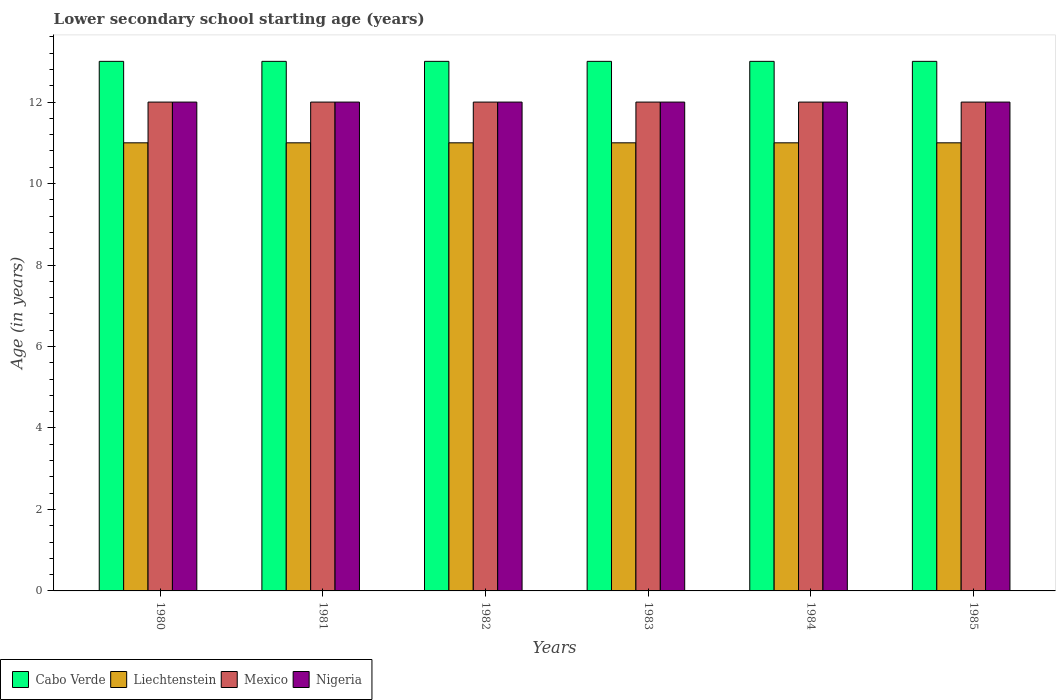How many groups of bars are there?
Give a very brief answer. 6. Are the number of bars on each tick of the X-axis equal?
Offer a very short reply. Yes. How many bars are there on the 5th tick from the right?
Make the answer very short. 4. What is the label of the 1st group of bars from the left?
Provide a short and direct response. 1980. In how many cases, is the number of bars for a given year not equal to the number of legend labels?
Your answer should be compact. 0. What is the lower secondary school starting age of children in Nigeria in 1980?
Your answer should be compact. 12. Across all years, what is the maximum lower secondary school starting age of children in Liechtenstein?
Your answer should be compact. 11. Across all years, what is the minimum lower secondary school starting age of children in Liechtenstein?
Give a very brief answer. 11. In which year was the lower secondary school starting age of children in Mexico minimum?
Your answer should be very brief. 1980. What is the total lower secondary school starting age of children in Mexico in the graph?
Give a very brief answer. 72. What is the difference between the lower secondary school starting age of children in Mexico in 1981 and the lower secondary school starting age of children in Liechtenstein in 1980?
Your response must be concise. 1. What is the average lower secondary school starting age of children in Liechtenstein per year?
Your response must be concise. 11. In the year 1984, what is the difference between the lower secondary school starting age of children in Mexico and lower secondary school starting age of children in Nigeria?
Your answer should be compact. 0. In how many years, is the lower secondary school starting age of children in Liechtenstein greater than 8.4 years?
Your response must be concise. 6. What is the ratio of the lower secondary school starting age of children in Mexico in 1982 to that in 1983?
Offer a terse response. 1. Is the lower secondary school starting age of children in Cabo Verde in 1983 less than that in 1985?
Offer a terse response. No. Is the difference between the lower secondary school starting age of children in Mexico in 1981 and 1983 greater than the difference between the lower secondary school starting age of children in Nigeria in 1981 and 1983?
Keep it short and to the point. No. What is the difference between the highest and the lowest lower secondary school starting age of children in Cabo Verde?
Keep it short and to the point. 0. What does the 2nd bar from the left in 1981 represents?
Offer a very short reply. Liechtenstein. What does the 3rd bar from the right in 1980 represents?
Provide a short and direct response. Liechtenstein. How many years are there in the graph?
Offer a very short reply. 6. What is the difference between two consecutive major ticks on the Y-axis?
Your answer should be very brief. 2. Does the graph contain grids?
Offer a very short reply. No. How many legend labels are there?
Your answer should be compact. 4. How are the legend labels stacked?
Give a very brief answer. Horizontal. What is the title of the graph?
Give a very brief answer. Lower secondary school starting age (years). What is the label or title of the Y-axis?
Provide a short and direct response. Age (in years). What is the Age (in years) in Cabo Verde in 1980?
Make the answer very short. 13. What is the Age (in years) of Liechtenstein in 1980?
Your answer should be very brief. 11. What is the Age (in years) of Mexico in 1980?
Your answer should be compact. 12. What is the Age (in years) of Nigeria in 1980?
Provide a short and direct response. 12. What is the Age (in years) of Liechtenstein in 1982?
Provide a short and direct response. 11. What is the Age (in years) in Cabo Verde in 1983?
Provide a short and direct response. 13. What is the Age (in years) of Cabo Verde in 1984?
Provide a short and direct response. 13. What is the Age (in years) of Liechtenstein in 1984?
Give a very brief answer. 11. What is the Age (in years) of Mexico in 1984?
Offer a terse response. 12. What is the Age (in years) of Nigeria in 1984?
Offer a very short reply. 12. What is the Age (in years) in Cabo Verde in 1985?
Provide a succinct answer. 13. What is the Age (in years) in Mexico in 1985?
Your answer should be very brief. 12. What is the Age (in years) of Nigeria in 1985?
Keep it short and to the point. 12. Across all years, what is the maximum Age (in years) of Cabo Verde?
Keep it short and to the point. 13. Across all years, what is the maximum Age (in years) in Mexico?
Offer a terse response. 12. Across all years, what is the minimum Age (in years) of Cabo Verde?
Offer a terse response. 13. Across all years, what is the minimum Age (in years) of Nigeria?
Make the answer very short. 12. What is the total Age (in years) in Cabo Verde in the graph?
Your answer should be compact. 78. What is the total Age (in years) in Liechtenstein in the graph?
Provide a succinct answer. 66. What is the difference between the Age (in years) of Nigeria in 1980 and that in 1981?
Your answer should be compact. 0. What is the difference between the Age (in years) of Cabo Verde in 1980 and that in 1982?
Provide a succinct answer. 0. What is the difference between the Age (in years) of Liechtenstein in 1980 and that in 1982?
Your answer should be compact. 0. What is the difference between the Age (in years) in Mexico in 1980 and that in 1982?
Ensure brevity in your answer.  0. What is the difference between the Age (in years) in Cabo Verde in 1980 and that in 1983?
Your response must be concise. 0. What is the difference between the Age (in years) in Liechtenstein in 1980 and that in 1983?
Offer a very short reply. 0. What is the difference between the Age (in years) in Cabo Verde in 1980 and that in 1984?
Your answer should be very brief. 0. What is the difference between the Age (in years) of Mexico in 1980 and that in 1984?
Your answer should be compact. 0. What is the difference between the Age (in years) in Nigeria in 1980 and that in 1984?
Give a very brief answer. 0. What is the difference between the Age (in years) of Cabo Verde in 1980 and that in 1985?
Provide a short and direct response. 0. What is the difference between the Age (in years) of Liechtenstein in 1980 and that in 1985?
Provide a succinct answer. 0. What is the difference between the Age (in years) of Mexico in 1981 and that in 1982?
Keep it short and to the point. 0. What is the difference between the Age (in years) in Nigeria in 1981 and that in 1982?
Your answer should be compact. 0. What is the difference between the Age (in years) of Cabo Verde in 1981 and that in 1983?
Provide a succinct answer. 0. What is the difference between the Age (in years) in Mexico in 1981 and that in 1983?
Offer a very short reply. 0. What is the difference between the Age (in years) in Mexico in 1981 and that in 1984?
Provide a short and direct response. 0. What is the difference between the Age (in years) in Mexico in 1982 and that in 1983?
Ensure brevity in your answer.  0. What is the difference between the Age (in years) of Cabo Verde in 1982 and that in 1984?
Your answer should be compact. 0. What is the difference between the Age (in years) of Nigeria in 1982 and that in 1984?
Ensure brevity in your answer.  0. What is the difference between the Age (in years) in Cabo Verde in 1982 and that in 1985?
Keep it short and to the point. 0. What is the difference between the Age (in years) in Liechtenstein in 1982 and that in 1985?
Make the answer very short. 0. What is the difference between the Age (in years) in Nigeria in 1983 and that in 1984?
Ensure brevity in your answer.  0. What is the difference between the Age (in years) in Liechtenstein in 1983 and that in 1985?
Your answer should be compact. 0. What is the difference between the Age (in years) of Cabo Verde in 1984 and that in 1985?
Your answer should be very brief. 0. What is the difference between the Age (in years) in Mexico in 1984 and that in 1985?
Your answer should be compact. 0. What is the difference between the Age (in years) in Cabo Verde in 1980 and the Age (in years) in Liechtenstein in 1981?
Make the answer very short. 2. What is the difference between the Age (in years) of Liechtenstein in 1980 and the Age (in years) of Nigeria in 1981?
Make the answer very short. -1. What is the difference between the Age (in years) in Cabo Verde in 1980 and the Age (in years) in Liechtenstein in 1983?
Ensure brevity in your answer.  2. What is the difference between the Age (in years) in Cabo Verde in 1980 and the Age (in years) in Nigeria in 1983?
Make the answer very short. 1. What is the difference between the Age (in years) of Liechtenstein in 1980 and the Age (in years) of Mexico in 1983?
Give a very brief answer. -1. What is the difference between the Age (in years) of Mexico in 1980 and the Age (in years) of Nigeria in 1983?
Your response must be concise. 0. What is the difference between the Age (in years) of Cabo Verde in 1980 and the Age (in years) of Liechtenstein in 1984?
Your answer should be compact. 2. What is the difference between the Age (in years) in Cabo Verde in 1980 and the Age (in years) in Mexico in 1984?
Provide a succinct answer. 1. What is the difference between the Age (in years) of Mexico in 1980 and the Age (in years) of Nigeria in 1984?
Provide a succinct answer. 0. What is the difference between the Age (in years) in Cabo Verde in 1980 and the Age (in years) in Liechtenstein in 1985?
Keep it short and to the point. 2. What is the difference between the Age (in years) in Liechtenstein in 1980 and the Age (in years) in Mexico in 1985?
Offer a terse response. -1. What is the difference between the Age (in years) in Liechtenstein in 1980 and the Age (in years) in Nigeria in 1985?
Provide a succinct answer. -1. What is the difference between the Age (in years) of Mexico in 1980 and the Age (in years) of Nigeria in 1985?
Offer a very short reply. 0. What is the difference between the Age (in years) of Cabo Verde in 1981 and the Age (in years) of Liechtenstein in 1982?
Your answer should be compact. 2. What is the difference between the Age (in years) in Cabo Verde in 1981 and the Age (in years) in Nigeria in 1982?
Offer a terse response. 1. What is the difference between the Age (in years) of Liechtenstein in 1981 and the Age (in years) of Nigeria in 1982?
Provide a short and direct response. -1. What is the difference between the Age (in years) in Cabo Verde in 1981 and the Age (in years) in Liechtenstein in 1983?
Offer a terse response. 2. What is the difference between the Age (in years) of Cabo Verde in 1981 and the Age (in years) of Mexico in 1983?
Your answer should be very brief. 1. What is the difference between the Age (in years) in Cabo Verde in 1981 and the Age (in years) in Nigeria in 1983?
Make the answer very short. 1. What is the difference between the Age (in years) in Liechtenstein in 1981 and the Age (in years) in Nigeria in 1983?
Your answer should be compact. -1. What is the difference between the Age (in years) in Cabo Verde in 1981 and the Age (in years) in Liechtenstein in 1984?
Your response must be concise. 2. What is the difference between the Age (in years) of Cabo Verde in 1981 and the Age (in years) of Nigeria in 1984?
Provide a succinct answer. 1. What is the difference between the Age (in years) in Liechtenstein in 1981 and the Age (in years) in Nigeria in 1984?
Provide a short and direct response. -1. What is the difference between the Age (in years) in Cabo Verde in 1981 and the Age (in years) in Mexico in 1985?
Keep it short and to the point. 1. What is the difference between the Age (in years) in Liechtenstein in 1981 and the Age (in years) in Nigeria in 1985?
Ensure brevity in your answer.  -1. What is the difference between the Age (in years) in Cabo Verde in 1982 and the Age (in years) in Nigeria in 1983?
Offer a very short reply. 1. What is the difference between the Age (in years) of Liechtenstein in 1982 and the Age (in years) of Nigeria in 1983?
Offer a terse response. -1. What is the difference between the Age (in years) of Liechtenstein in 1982 and the Age (in years) of Mexico in 1984?
Your response must be concise. -1. What is the difference between the Age (in years) of Cabo Verde in 1982 and the Age (in years) of Mexico in 1985?
Offer a very short reply. 1. What is the difference between the Age (in years) of Cabo Verde in 1982 and the Age (in years) of Nigeria in 1985?
Give a very brief answer. 1. What is the difference between the Age (in years) in Liechtenstein in 1982 and the Age (in years) in Mexico in 1985?
Your answer should be compact. -1. What is the difference between the Age (in years) of Liechtenstein in 1982 and the Age (in years) of Nigeria in 1985?
Provide a short and direct response. -1. What is the difference between the Age (in years) in Cabo Verde in 1983 and the Age (in years) in Liechtenstein in 1984?
Give a very brief answer. 2. What is the difference between the Age (in years) of Cabo Verde in 1983 and the Age (in years) of Mexico in 1984?
Make the answer very short. 1. What is the difference between the Age (in years) in Cabo Verde in 1983 and the Age (in years) in Nigeria in 1984?
Provide a succinct answer. 1. What is the difference between the Age (in years) of Liechtenstein in 1983 and the Age (in years) of Nigeria in 1984?
Your response must be concise. -1. What is the difference between the Age (in years) in Mexico in 1983 and the Age (in years) in Nigeria in 1984?
Your answer should be compact. 0. What is the difference between the Age (in years) of Cabo Verde in 1983 and the Age (in years) of Liechtenstein in 1985?
Your answer should be compact. 2. What is the difference between the Age (in years) in Cabo Verde in 1983 and the Age (in years) in Nigeria in 1985?
Offer a very short reply. 1. What is the difference between the Age (in years) in Liechtenstein in 1983 and the Age (in years) in Mexico in 1985?
Your response must be concise. -1. What is the difference between the Age (in years) of Cabo Verde in 1984 and the Age (in years) of Mexico in 1985?
Give a very brief answer. 1. What is the average Age (in years) of Mexico per year?
Offer a very short reply. 12. In the year 1980, what is the difference between the Age (in years) of Cabo Verde and Age (in years) of Liechtenstein?
Provide a short and direct response. 2. In the year 1980, what is the difference between the Age (in years) in Cabo Verde and Age (in years) in Nigeria?
Provide a succinct answer. 1. In the year 1980, what is the difference between the Age (in years) of Liechtenstein and Age (in years) of Nigeria?
Make the answer very short. -1. In the year 1980, what is the difference between the Age (in years) of Mexico and Age (in years) of Nigeria?
Offer a terse response. 0. In the year 1981, what is the difference between the Age (in years) of Cabo Verde and Age (in years) of Liechtenstein?
Provide a succinct answer. 2. In the year 1981, what is the difference between the Age (in years) in Liechtenstein and Age (in years) in Mexico?
Keep it short and to the point. -1. In the year 1981, what is the difference between the Age (in years) of Liechtenstein and Age (in years) of Nigeria?
Keep it short and to the point. -1. In the year 1982, what is the difference between the Age (in years) of Cabo Verde and Age (in years) of Liechtenstein?
Provide a succinct answer. 2. In the year 1983, what is the difference between the Age (in years) of Cabo Verde and Age (in years) of Mexico?
Your response must be concise. 1. In the year 1984, what is the difference between the Age (in years) in Cabo Verde and Age (in years) in Liechtenstein?
Give a very brief answer. 2. In the year 1984, what is the difference between the Age (in years) in Cabo Verde and Age (in years) in Nigeria?
Your answer should be very brief. 1. In the year 1984, what is the difference between the Age (in years) of Liechtenstein and Age (in years) of Mexico?
Give a very brief answer. -1. In the year 1984, what is the difference between the Age (in years) of Mexico and Age (in years) of Nigeria?
Keep it short and to the point. 0. In the year 1985, what is the difference between the Age (in years) of Cabo Verde and Age (in years) of Liechtenstein?
Offer a very short reply. 2. In the year 1985, what is the difference between the Age (in years) in Cabo Verde and Age (in years) in Nigeria?
Your answer should be compact. 1. In the year 1985, what is the difference between the Age (in years) in Liechtenstein and Age (in years) in Mexico?
Provide a short and direct response. -1. In the year 1985, what is the difference between the Age (in years) in Mexico and Age (in years) in Nigeria?
Offer a terse response. 0. What is the ratio of the Age (in years) of Liechtenstein in 1980 to that in 1981?
Provide a succinct answer. 1. What is the ratio of the Age (in years) in Mexico in 1980 to that in 1981?
Offer a terse response. 1. What is the ratio of the Age (in years) in Cabo Verde in 1980 to that in 1982?
Give a very brief answer. 1. What is the ratio of the Age (in years) in Liechtenstein in 1980 to that in 1982?
Ensure brevity in your answer.  1. What is the ratio of the Age (in years) in Nigeria in 1980 to that in 1982?
Your answer should be compact. 1. What is the ratio of the Age (in years) in Cabo Verde in 1980 to that in 1983?
Offer a very short reply. 1. What is the ratio of the Age (in years) of Mexico in 1980 to that in 1983?
Offer a terse response. 1. What is the ratio of the Age (in years) in Nigeria in 1980 to that in 1984?
Keep it short and to the point. 1. What is the ratio of the Age (in years) in Liechtenstein in 1980 to that in 1985?
Give a very brief answer. 1. What is the ratio of the Age (in years) in Nigeria in 1980 to that in 1985?
Your answer should be very brief. 1. What is the ratio of the Age (in years) in Cabo Verde in 1981 to that in 1982?
Give a very brief answer. 1. What is the ratio of the Age (in years) of Liechtenstein in 1981 to that in 1982?
Your answer should be very brief. 1. What is the ratio of the Age (in years) of Mexico in 1981 to that in 1982?
Make the answer very short. 1. What is the ratio of the Age (in years) in Nigeria in 1981 to that in 1982?
Your answer should be compact. 1. What is the ratio of the Age (in years) in Liechtenstein in 1981 to that in 1983?
Your answer should be very brief. 1. What is the ratio of the Age (in years) in Mexico in 1981 to that in 1983?
Provide a succinct answer. 1. What is the ratio of the Age (in years) in Cabo Verde in 1981 to that in 1984?
Offer a very short reply. 1. What is the ratio of the Age (in years) of Liechtenstein in 1981 to that in 1984?
Ensure brevity in your answer.  1. What is the ratio of the Age (in years) of Mexico in 1981 to that in 1984?
Provide a short and direct response. 1. What is the ratio of the Age (in years) of Nigeria in 1981 to that in 1984?
Your answer should be compact. 1. What is the ratio of the Age (in years) in Cabo Verde in 1981 to that in 1985?
Make the answer very short. 1. What is the ratio of the Age (in years) of Mexico in 1982 to that in 1983?
Your response must be concise. 1. What is the ratio of the Age (in years) in Liechtenstein in 1982 to that in 1984?
Make the answer very short. 1. What is the ratio of the Age (in years) in Cabo Verde in 1982 to that in 1985?
Provide a succinct answer. 1. What is the ratio of the Age (in years) of Mexico in 1982 to that in 1985?
Ensure brevity in your answer.  1. What is the ratio of the Age (in years) of Nigeria in 1982 to that in 1985?
Ensure brevity in your answer.  1. What is the ratio of the Age (in years) of Liechtenstein in 1983 to that in 1984?
Provide a short and direct response. 1. What is the ratio of the Age (in years) in Cabo Verde in 1983 to that in 1985?
Ensure brevity in your answer.  1. What is the ratio of the Age (in years) of Mexico in 1983 to that in 1985?
Keep it short and to the point. 1. What is the ratio of the Age (in years) of Liechtenstein in 1984 to that in 1985?
Offer a very short reply. 1. What is the ratio of the Age (in years) of Nigeria in 1984 to that in 1985?
Make the answer very short. 1. What is the difference between the highest and the second highest Age (in years) in Cabo Verde?
Make the answer very short. 0. What is the difference between the highest and the second highest Age (in years) of Mexico?
Keep it short and to the point. 0. What is the difference between the highest and the lowest Age (in years) in Liechtenstein?
Offer a very short reply. 0. What is the difference between the highest and the lowest Age (in years) of Mexico?
Provide a succinct answer. 0. 